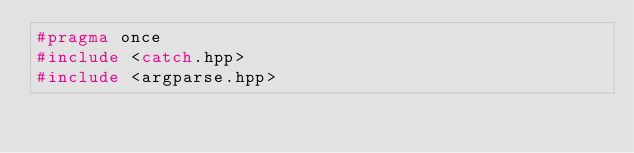Convert code to text. <code><loc_0><loc_0><loc_500><loc_500><_C++_>#pragma once
#include <catch.hpp>
#include <argparse.hpp>
</code> 